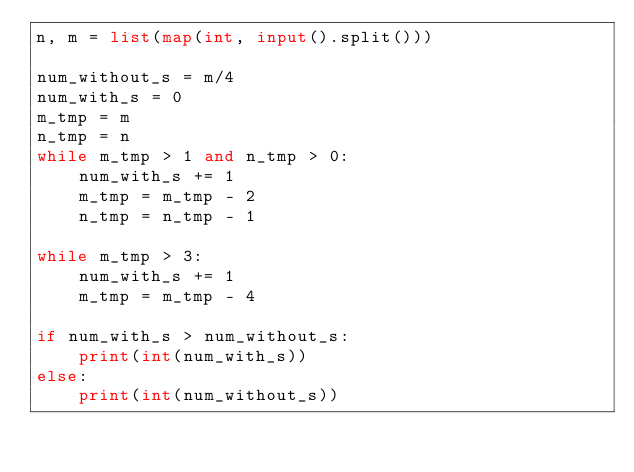Convert code to text. <code><loc_0><loc_0><loc_500><loc_500><_Python_>n, m = list(map(int, input().split()))

num_without_s = m/4
num_with_s = 0
m_tmp = m
n_tmp = n
while m_tmp > 1 and n_tmp > 0:
    num_with_s += 1
    m_tmp = m_tmp - 2
    n_tmp = n_tmp - 1

while m_tmp > 3:
    num_with_s += 1
    m_tmp = m_tmp - 4

if num_with_s > num_without_s:
    print(int(num_with_s))
else:
    print(int(num_without_s))
    </code> 